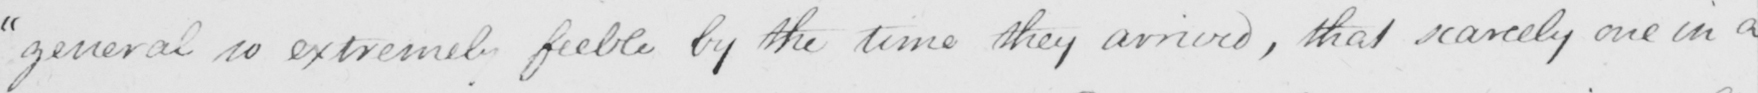Can you read and transcribe this handwriting? general so extremely feeble by the time they arrived , that scarcely one in a 